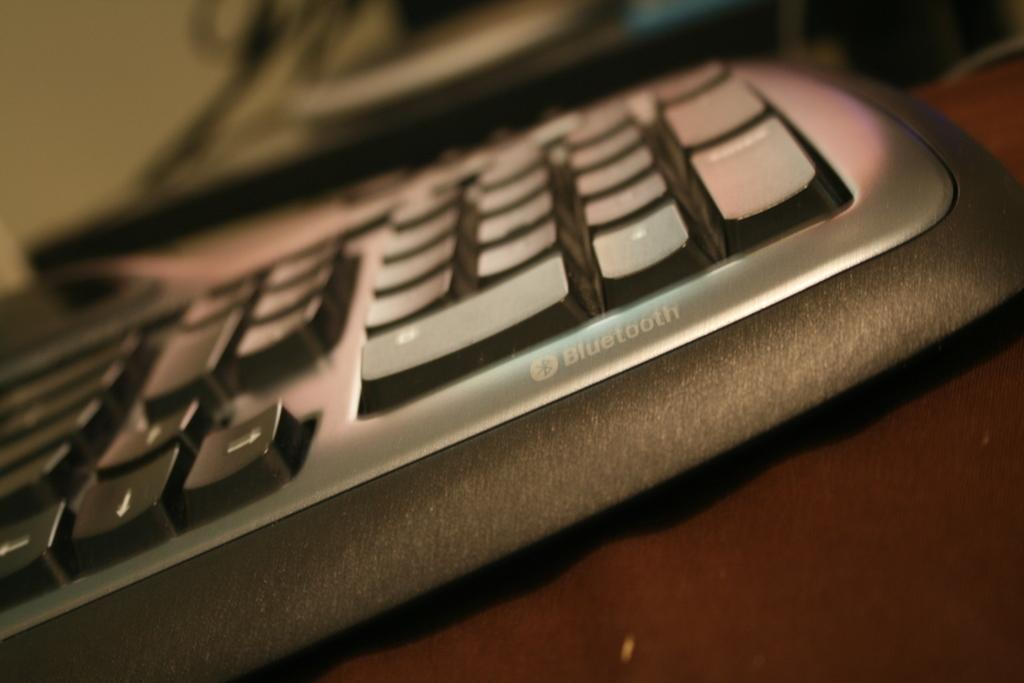What is the main object in the image? There is a keyboard in the image. Is there any text visible on the keyboard? Yes, the keyboard has some text on it. On what surface is the keyboard placed? The keyboard is placed on a surface. What type of gold material is used to make the keyboard? The keyboard is not made of gold; it is likely made of plastic or another material. What type of steel structure is supporting the keyboard in the image? There is no steel structure visible in the image; the keyboard is simply placed on a surface. 